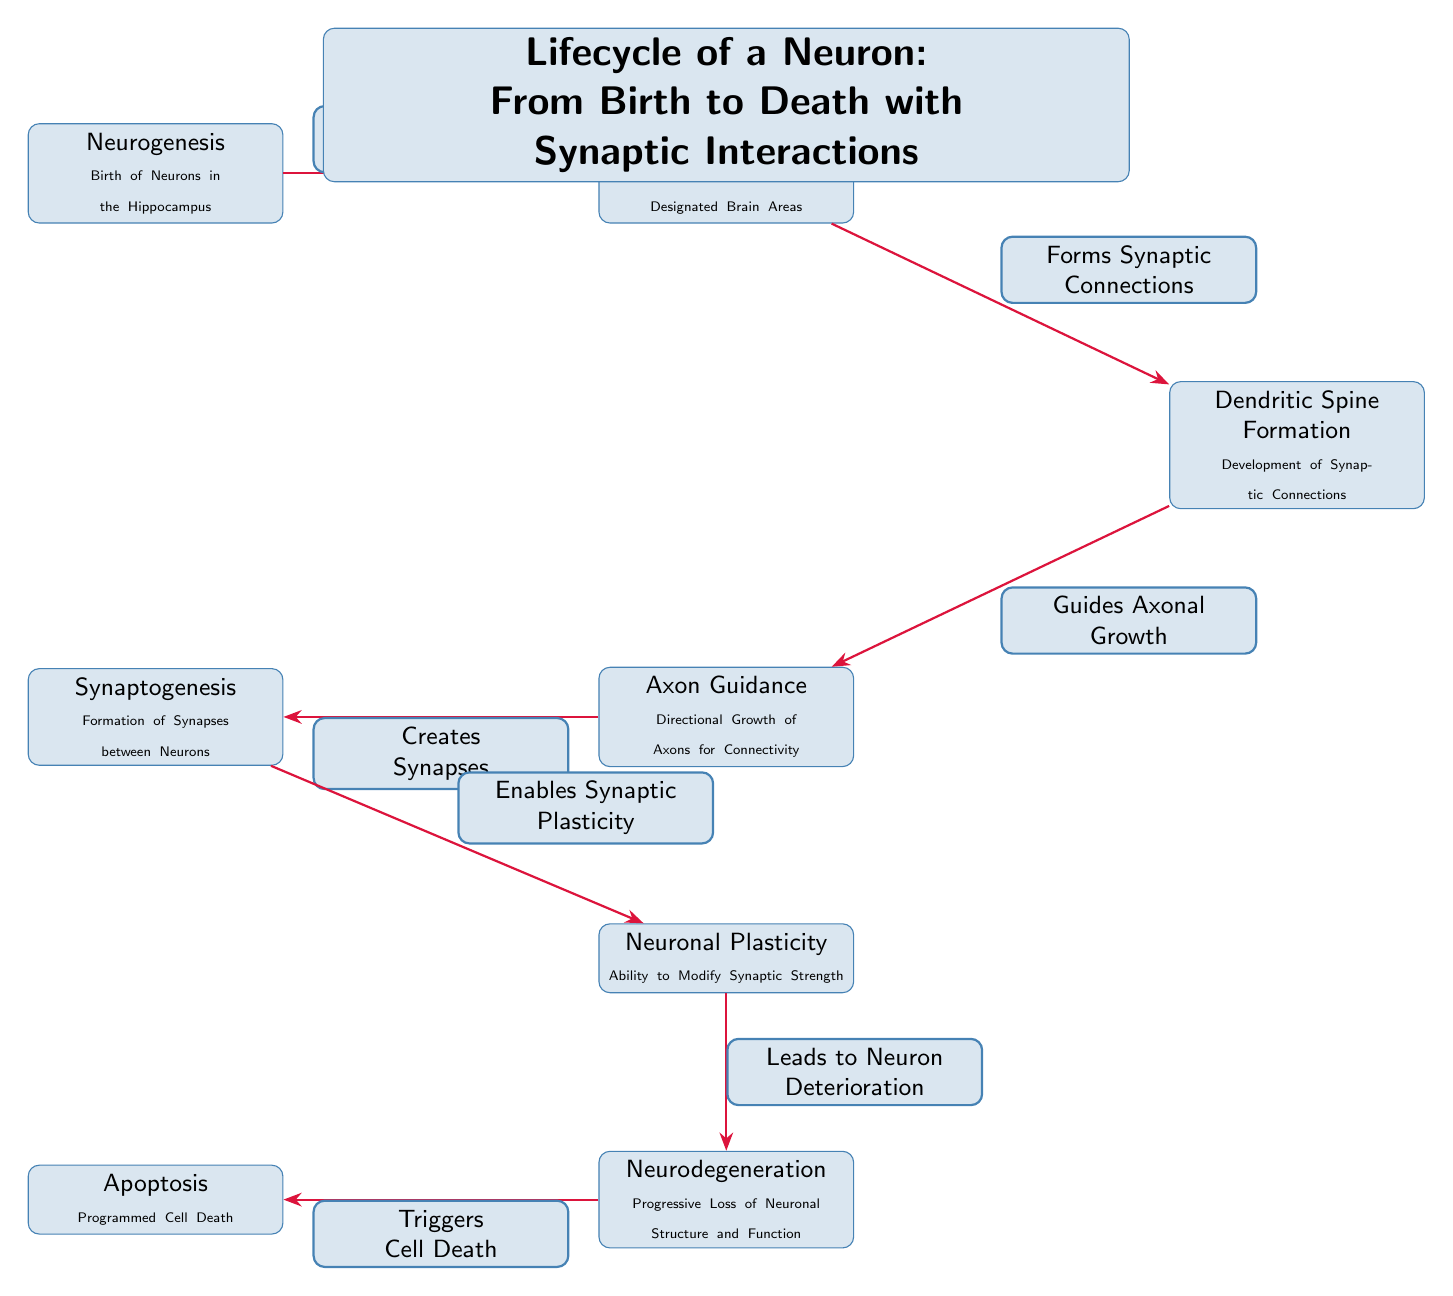What is the first stage in the neuronal lifecycle? The first stage listed in the diagram is "Neurogenesis," which is the birth of neurons in the hippocampus.
Answer: Neurogenesis How many nodes are present in the diagram? The diagram contains a total of eight nodes representing different stages in the neuron lifecycle.
Answer: 8 Which node follows Neuronal Migration? According to the diagram, "Dendritic Spine Formation" follows "Neuronal Migration."
Answer: Dendritic Spine Formation What is the relationship between Synaptogenesis and Neuronal Plasticity? The diagram indicates that Synaptogenesis enables Neuronal Plasticity, highlighting how synapse formation influences the ability to modify synaptic strength.
Answer: Enables Synaptic Plasticity What triggers Apoptosis according to the diagram? The diagram states that Neurodegeneration triggers Apoptosis, indicating a cause-and-effect relationship between these two processes in the neuronal lifecycle.
Answer: Triggers Cell Death What is the purpose of Axon Guidance in the lifecycle? The diagram explains that Axon Guidance is responsible for the directional growth of axons for connectivity, showing its role in establishing connections in the brain.
Answer: Directional Growth of Axons for Connectivity Which stage is characterized by the progressive loss of neuronal structure? The diagram identifies "Neurodegeneration" as the stage characterized by progressive loss of neuronal structure and function.
Answer: Neurodegeneration How does Dendritic Spine Formation relate to Synaptogenesis? The diagram shows that Dendritic Spine Formation forms synaptic connections, making it a critical step leading to Synaptogenesis in the neuronal lifecycle.
Answer: Forms Synaptic Connections 